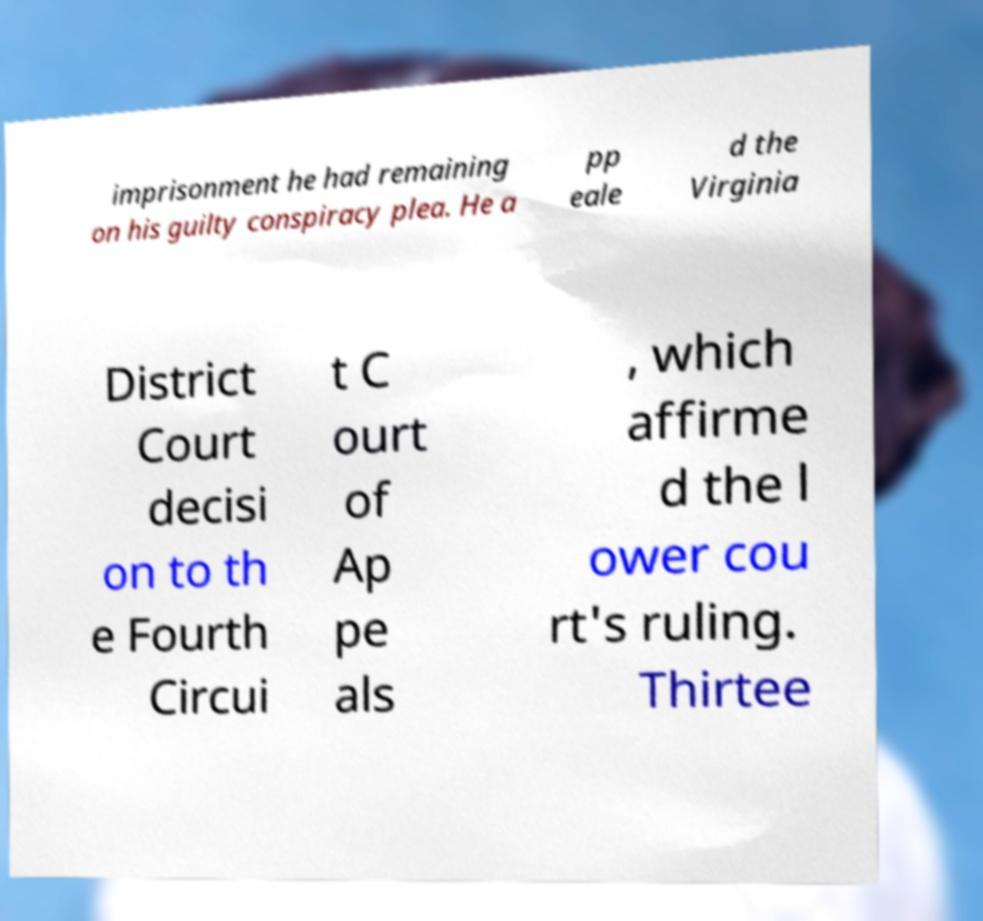There's text embedded in this image that I need extracted. Can you transcribe it verbatim? imprisonment he had remaining on his guilty conspiracy plea. He a pp eale d the Virginia District Court decisi on to th e Fourth Circui t C ourt of Ap pe als , which affirme d the l ower cou rt's ruling. Thirtee 